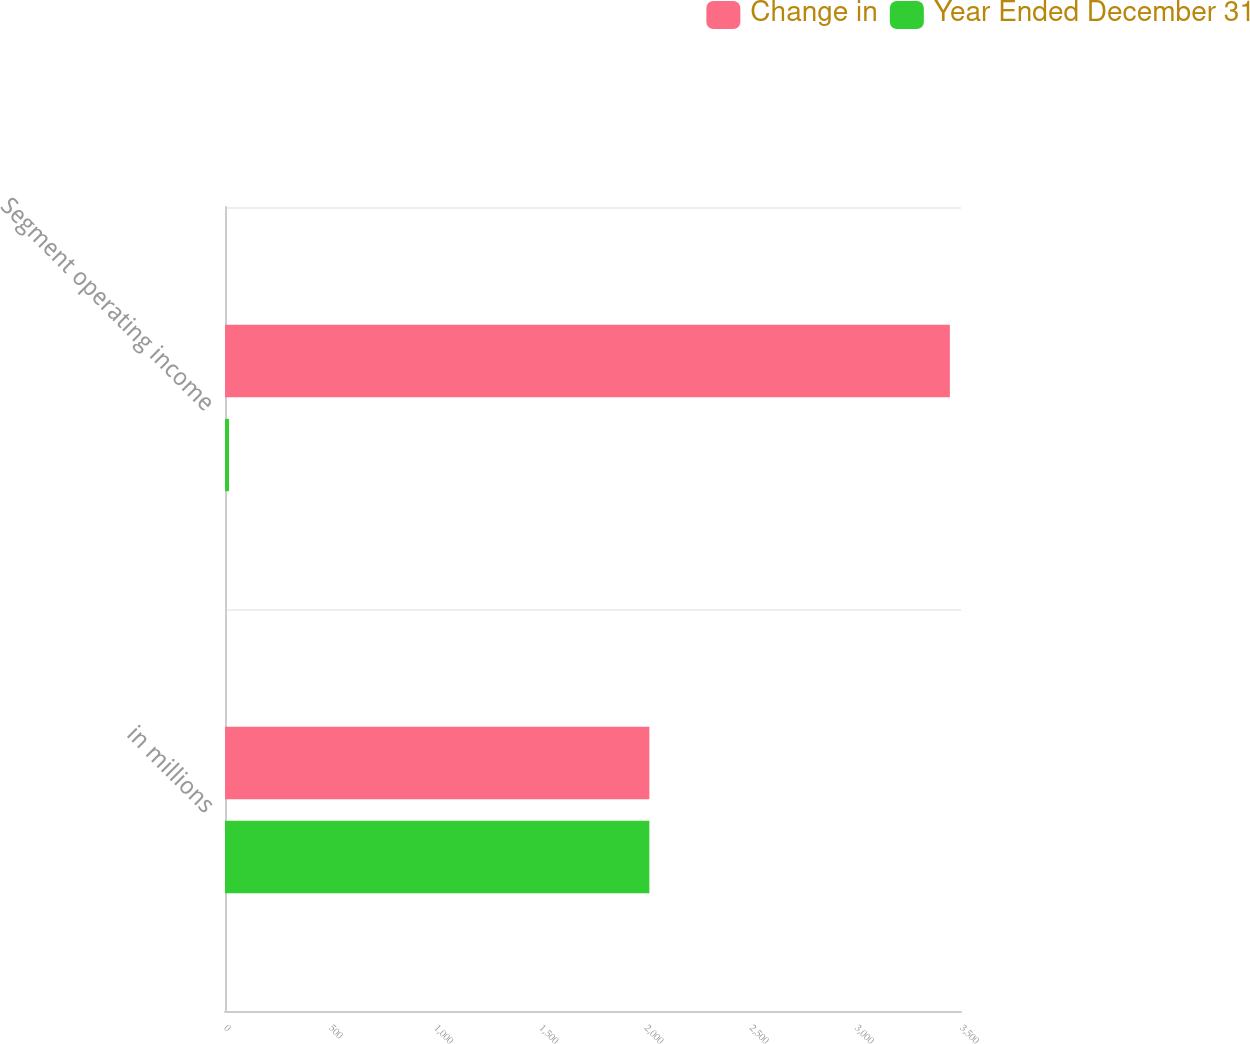Convert chart. <chart><loc_0><loc_0><loc_500><loc_500><stacked_bar_chart><ecel><fcel>in millions<fcel>Segment operating income<nl><fcel>Change in<fcel>2018<fcel>3447<nl><fcel>Year Ended December 31<fcel>2018<fcel>19<nl></chart> 